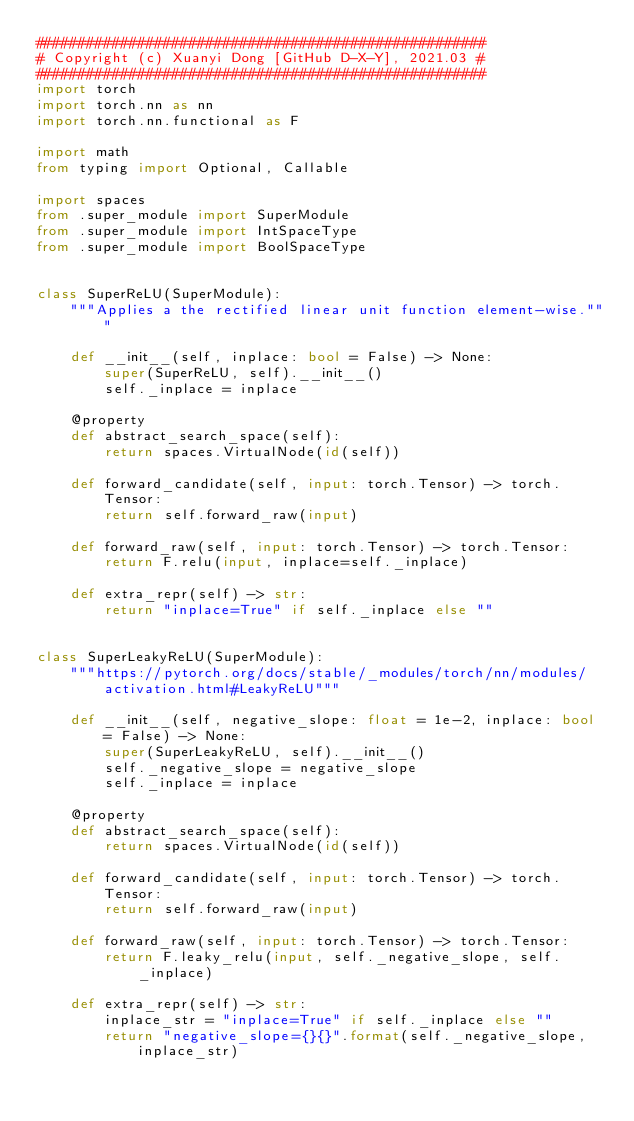Convert code to text. <code><loc_0><loc_0><loc_500><loc_500><_Python_>#####################################################
# Copyright (c) Xuanyi Dong [GitHub D-X-Y], 2021.03 #
#####################################################
import torch
import torch.nn as nn
import torch.nn.functional as F

import math
from typing import Optional, Callable

import spaces
from .super_module import SuperModule
from .super_module import IntSpaceType
from .super_module import BoolSpaceType


class SuperReLU(SuperModule):
    """Applies a the rectified linear unit function element-wise."""

    def __init__(self, inplace: bool = False) -> None:
        super(SuperReLU, self).__init__()
        self._inplace = inplace

    @property
    def abstract_search_space(self):
        return spaces.VirtualNode(id(self))

    def forward_candidate(self, input: torch.Tensor) -> torch.Tensor:
        return self.forward_raw(input)

    def forward_raw(self, input: torch.Tensor) -> torch.Tensor:
        return F.relu(input, inplace=self._inplace)

    def extra_repr(self) -> str:
        return "inplace=True" if self._inplace else ""


class SuperLeakyReLU(SuperModule):
    """https://pytorch.org/docs/stable/_modules/torch/nn/modules/activation.html#LeakyReLU"""

    def __init__(self, negative_slope: float = 1e-2, inplace: bool = False) -> None:
        super(SuperLeakyReLU, self).__init__()
        self._negative_slope = negative_slope
        self._inplace = inplace

    @property
    def abstract_search_space(self):
        return spaces.VirtualNode(id(self))

    def forward_candidate(self, input: torch.Tensor) -> torch.Tensor:
        return self.forward_raw(input)

    def forward_raw(self, input: torch.Tensor) -> torch.Tensor:
        return F.leaky_relu(input, self._negative_slope, self._inplace)

    def extra_repr(self) -> str:
        inplace_str = "inplace=True" if self._inplace else ""
        return "negative_slope={}{}".format(self._negative_slope, inplace_str)
</code> 